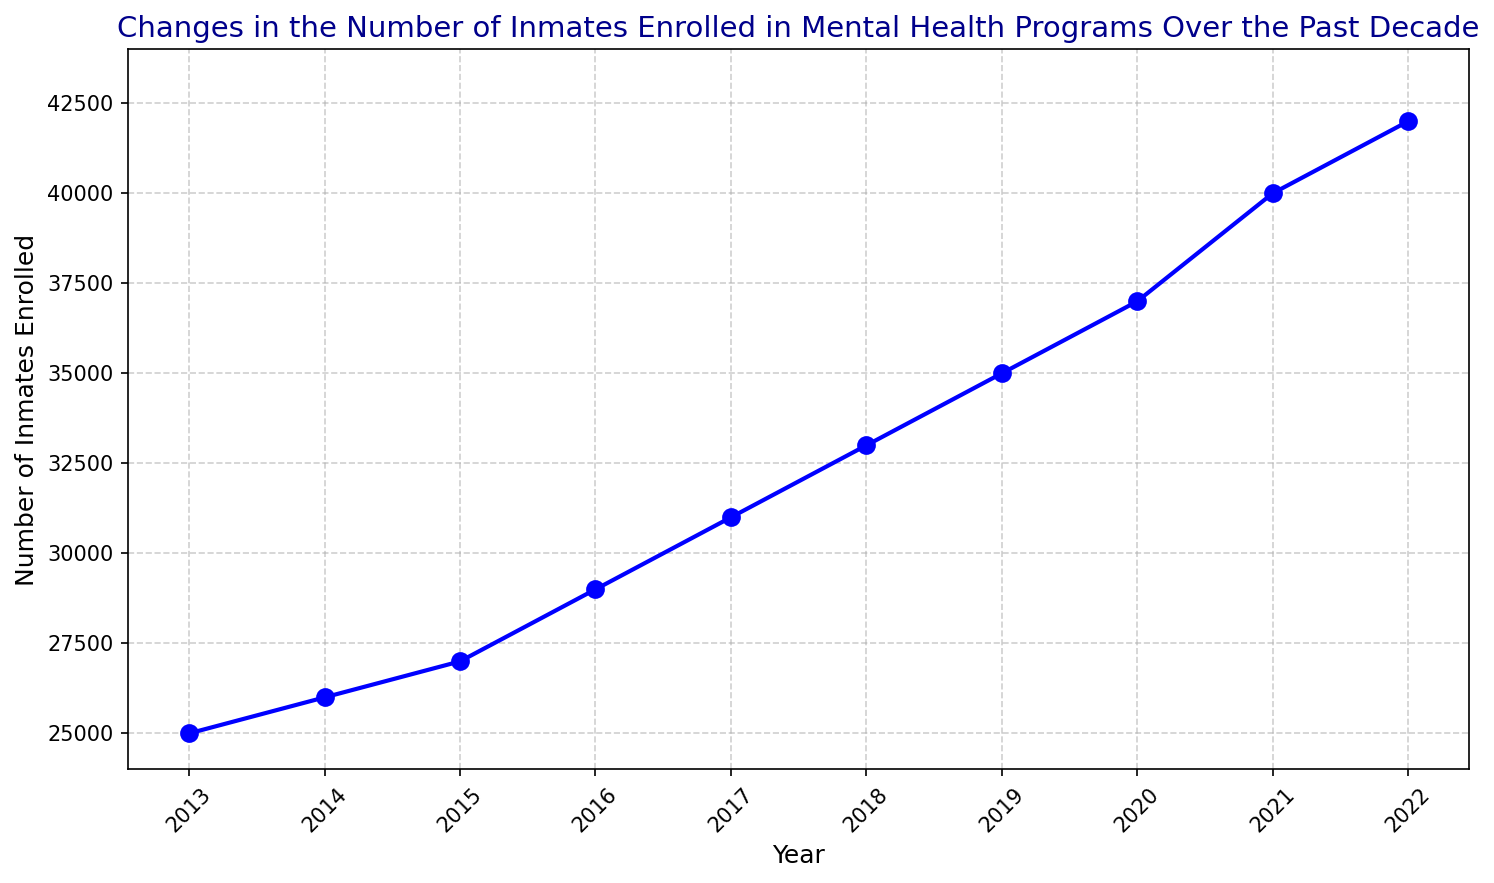What's the overall trend in the number of inmates enrolled in mental health programs over the past decade? The line chart shows a noticeable upward trend from 2013 to 2022. Starting at 25,000 in 2013, the number of enrolled inmates consistently increased each year, reaching 42,000 in 2022.
Answer: Upward trend In which year did the number of inmates enrolled in mental health programs see the largest increase from the previous year? To find the largest increase, we need to compare the differences between consecutive years. Comparing each gap, the largest increase occurs between 2020 and 2021, where the rise is from 37,000 to 40,000, an increase of 3,000.
Answer: 2021 What is the average number of inmates enrolled in mental health programs over the past decade? Sum all the values (25,000+26,000+27,000+29,000+31,000+33,000+35,000+37,000+40,000+42,000 = 325,000), then divide by the number of years (10). The average is 325,000 / 10 = 32,500.
Answer: 32,500 Compare the number of inmates enrolled in 2013 and 2022. How much has it increased? The number of inmates in 2013 was 25,000 while in 2022 it was 42,000. The increase is calculated by subtracting 25,000 from 42,000. So, 42,000 - 25,000 = 17,000.
Answer: 17,000 Which year had the lowest number of inmates enrolled in mental health programs? By examining the line chart, the lowest point is at 2013 with 25,000 inmates enrolled.
Answer: 2013 Between 2015 and 2018, what was the total increase in the number of inmates enrolled in mental health programs? The number in 2015 was 27,000 and in 2018 it was 33,000. The total increase can be calculated by subtracting 27,000 from 33,000, which gives 33,000 - 27,000 = 6,000.
Answer: 6,000 By visual examination, how would you describe the trend between 2014 and 2017? The chart shows a steady increase, with the number of inmates enrolled rising from 26,000 in 2014 to 31,000 in 2017. The increments are almost uniform each year.
Answer: Steady increase Compare the slope of the line between 2016 and 2020. What does this indicate about the rate of increase in those years? The slope between 2016 (29,000) and 2020 (37,000) shows a consistent upward trend. The slope is moderately steep, indicating a steady rate of increase each year in that period.
Answer: Steady Do any years show a plateau in the number of inmates enrolled in mental health programs? By inspecting the line chart, there are no apparent plateaus; the number increases every year without leveling off.
Answer: No 